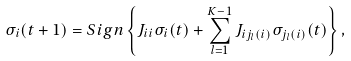<formula> <loc_0><loc_0><loc_500><loc_500>\sigma _ { i } ( t + 1 ) = S i g n \left \{ J _ { i i } \sigma _ { i } ( t ) + \sum _ { l = 1 } ^ { K - 1 } J _ { i j _ { l } ( i ) } \sigma _ { j _ { l } ( i ) } ( t ) \right \} ,</formula> 